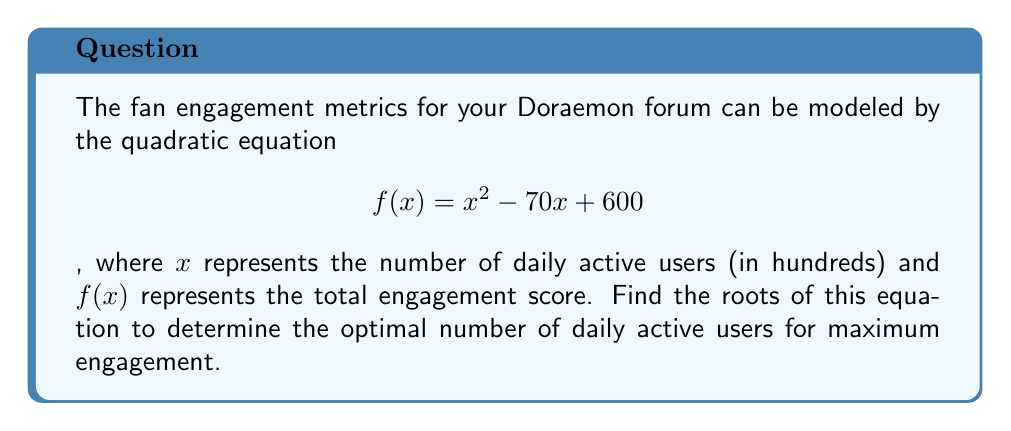Show me your answer to this math problem. To find the roots of the quadratic equation, we'll use the quadratic formula:

$$ x = \frac{-b \pm \sqrt{b^2 - 4ac}}{2a} $$

Where $a = 1$, $b = -70$, and $c = 600$

Step 1: Substitute the values into the quadratic formula:
$$ x = \frac{-(-70) \pm \sqrt{(-70)^2 - 4(1)(600)}}{2(1)} $$

Step 2: Simplify under the square root:
$$ x = \frac{70 \pm \sqrt{4900 - 2400}}{2} $$
$$ x = \frac{70 \pm \sqrt{2500}}{2} $$

Step 3: Simplify the square root:
$$ x = \frac{70 \pm 50}{2} $$

Step 4: Calculate the two roots:
$$ x_1 = \frac{70 + 50}{2} = \frac{120}{2} = 60 $$
$$ x_2 = \frac{70 - 50}{2} = \frac{20}{2} = 10 $$

The roots are 60 and 10, representing 6,000 and 1,000 daily active users respectively.
Answer: 6,000 and 1,000 daily active users 